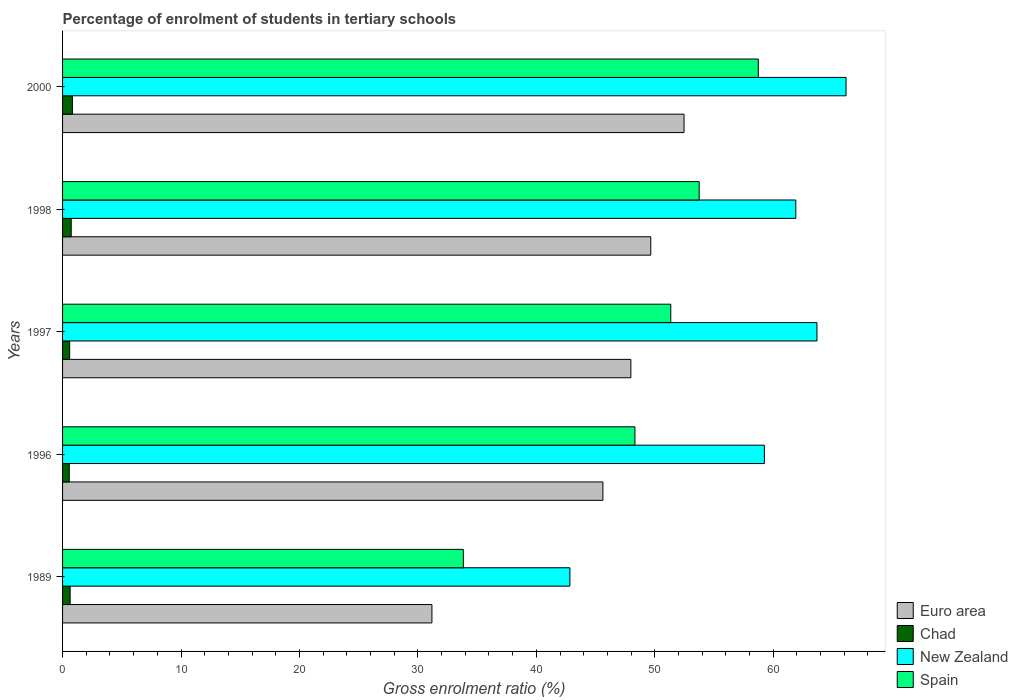How many groups of bars are there?
Your response must be concise. 5. What is the label of the 4th group of bars from the top?
Ensure brevity in your answer.  1996. In how many cases, is the number of bars for a given year not equal to the number of legend labels?
Keep it short and to the point. 0. What is the percentage of students enrolled in tertiary schools in Euro area in 2000?
Ensure brevity in your answer.  52.47. Across all years, what is the maximum percentage of students enrolled in tertiary schools in Chad?
Offer a terse response. 0.83. Across all years, what is the minimum percentage of students enrolled in tertiary schools in Spain?
Offer a terse response. 33.84. In which year was the percentage of students enrolled in tertiary schools in Spain maximum?
Your response must be concise. 2000. What is the total percentage of students enrolled in tertiary schools in New Zealand in the graph?
Give a very brief answer. 293.84. What is the difference between the percentage of students enrolled in tertiary schools in New Zealand in 1989 and that in 1996?
Your response must be concise. -16.42. What is the difference between the percentage of students enrolled in tertiary schools in Spain in 1996 and the percentage of students enrolled in tertiary schools in Chad in 1989?
Make the answer very short. 47.69. What is the average percentage of students enrolled in tertiary schools in Euro area per year?
Provide a succinct answer. 45.38. In the year 1997, what is the difference between the percentage of students enrolled in tertiary schools in New Zealand and percentage of students enrolled in tertiary schools in Spain?
Provide a short and direct response. 12.34. In how many years, is the percentage of students enrolled in tertiary schools in New Zealand greater than 60 %?
Make the answer very short. 3. What is the ratio of the percentage of students enrolled in tertiary schools in Euro area in 1989 to that in 1996?
Your response must be concise. 0.68. Is the percentage of students enrolled in tertiary schools in Chad in 1996 less than that in 1998?
Your answer should be very brief. Yes. What is the difference between the highest and the second highest percentage of students enrolled in tertiary schools in Euro area?
Offer a terse response. 2.81. What is the difference between the highest and the lowest percentage of students enrolled in tertiary schools in Spain?
Your answer should be very brief. 24.9. Is it the case that in every year, the sum of the percentage of students enrolled in tertiary schools in Chad and percentage of students enrolled in tertiary schools in Spain is greater than the sum of percentage of students enrolled in tertiary schools in Euro area and percentage of students enrolled in tertiary schools in New Zealand?
Keep it short and to the point. No. What does the 4th bar from the top in 1998 represents?
Give a very brief answer. Euro area. What does the 3rd bar from the bottom in 1998 represents?
Your answer should be very brief. New Zealand. Is it the case that in every year, the sum of the percentage of students enrolled in tertiary schools in Spain and percentage of students enrolled in tertiary schools in New Zealand is greater than the percentage of students enrolled in tertiary schools in Chad?
Make the answer very short. Yes. How many years are there in the graph?
Provide a short and direct response. 5. Does the graph contain any zero values?
Offer a very short reply. No. Does the graph contain grids?
Give a very brief answer. No. Where does the legend appear in the graph?
Give a very brief answer. Bottom right. What is the title of the graph?
Offer a very short reply. Percentage of enrolment of students in tertiary schools. Does "Benin" appear as one of the legend labels in the graph?
Offer a terse response. No. What is the label or title of the X-axis?
Your answer should be compact. Gross enrolment ratio (%). What is the label or title of the Y-axis?
Ensure brevity in your answer.  Years. What is the Gross enrolment ratio (%) of Euro area in 1989?
Your answer should be compact. 31.19. What is the Gross enrolment ratio (%) of Chad in 1989?
Provide a short and direct response. 0.64. What is the Gross enrolment ratio (%) in New Zealand in 1989?
Keep it short and to the point. 42.84. What is the Gross enrolment ratio (%) in Spain in 1989?
Ensure brevity in your answer.  33.84. What is the Gross enrolment ratio (%) in Euro area in 1996?
Ensure brevity in your answer.  45.62. What is the Gross enrolment ratio (%) of Chad in 1996?
Keep it short and to the point. 0.56. What is the Gross enrolment ratio (%) of New Zealand in 1996?
Provide a succinct answer. 59.26. What is the Gross enrolment ratio (%) of Spain in 1996?
Give a very brief answer. 48.33. What is the Gross enrolment ratio (%) in Euro area in 1997?
Make the answer very short. 47.98. What is the Gross enrolment ratio (%) in Chad in 1997?
Keep it short and to the point. 0.6. What is the Gross enrolment ratio (%) in New Zealand in 1997?
Your answer should be very brief. 63.69. What is the Gross enrolment ratio (%) of Spain in 1997?
Make the answer very short. 51.35. What is the Gross enrolment ratio (%) of Euro area in 1998?
Make the answer very short. 49.66. What is the Gross enrolment ratio (%) in Chad in 1998?
Make the answer very short. 0.73. What is the Gross enrolment ratio (%) in New Zealand in 1998?
Your response must be concise. 61.91. What is the Gross enrolment ratio (%) in Spain in 1998?
Provide a short and direct response. 53.75. What is the Gross enrolment ratio (%) in Euro area in 2000?
Give a very brief answer. 52.47. What is the Gross enrolment ratio (%) in Chad in 2000?
Offer a terse response. 0.83. What is the Gross enrolment ratio (%) in New Zealand in 2000?
Your answer should be very brief. 66.15. What is the Gross enrolment ratio (%) of Spain in 2000?
Give a very brief answer. 58.74. Across all years, what is the maximum Gross enrolment ratio (%) in Euro area?
Provide a short and direct response. 52.47. Across all years, what is the maximum Gross enrolment ratio (%) in Chad?
Your answer should be compact. 0.83. Across all years, what is the maximum Gross enrolment ratio (%) in New Zealand?
Your response must be concise. 66.15. Across all years, what is the maximum Gross enrolment ratio (%) in Spain?
Your answer should be compact. 58.74. Across all years, what is the minimum Gross enrolment ratio (%) in Euro area?
Your answer should be compact. 31.19. Across all years, what is the minimum Gross enrolment ratio (%) in Chad?
Give a very brief answer. 0.56. Across all years, what is the minimum Gross enrolment ratio (%) in New Zealand?
Offer a terse response. 42.84. Across all years, what is the minimum Gross enrolment ratio (%) in Spain?
Provide a succinct answer. 33.84. What is the total Gross enrolment ratio (%) of Euro area in the graph?
Your response must be concise. 226.92. What is the total Gross enrolment ratio (%) of Chad in the graph?
Your answer should be very brief. 3.37. What is the total Gross enrolment ratio (%) of New Zealand in the graph?
Offer a terse response. 293.84. What is the total Gross enrolment ratio (%) in Spain in the graph?
Provide a short and direct response. 246. What is the difference between the Gross enrolment ratio (%) in Euro area in 1989 and that in 1996?
Your answer should be very brief. -14.44. What is the difference between the Gross enrolment ratio (%) of Chad in 1989 and that in 1996?
Make the answer very short. 0.07. What is the difference between the Gross enrolment ratio (%) of New Zealand in 1989 and that in 1996?
Provide a short and direct response. -16.42. What is the difference between the Gross enrolment ratio (%) in Spain in 1989 and that in 1996?
Your answer should be very brief. -14.49. What is the difference between the Gross enrolment ratio (%) in Euro area in 1989 and that in 1997?
Make the answer very short. -16.79. What is the difference between the Gross enrolment ratio (%) in Chad in 1989 and that in 1997?
Provide a succinct answer. 0.04. What is the difference between the Gross enrolment ratio (%) of New Zealand in 1989 and that in 1997?
Keep it short and to the point. -20.86. What is the difference between the Gross enrolment ratio (%) of Spain in 1989 and that in 1997?
Ensure brevity in your answer.  -17.51. What is the difference between the Gross enrolment ratio (%) in Euro area in 1989 and that in 1998?
Offer a terse response. -18.48. What is the difference between the Gross enrolment ratio (%) in Chad in 1989 and that in 1998?
Offer a terse response. -0.09. What is the difference between the Gross enrolment ratio (%) in New Zealand in 1989 and that in 1998?
Give a very brief answer. -19.07. What is the difference between the Gross enrolment ratio (%) in Spain in 1989 and that in 1998?
Offer a terse response. -19.91. What is the difference between the Gross enrolment ratio (%) of Euro area in 1989 and that in 2000?
Your answer should be compact. -21.29. What is the difference between the Gross enrolment ratio (%) of Chad in 1989 and that in 2000?
Your response must be concise. -0.19. What is the difference between the Gross enrolment ratio (%) in New Zealand in 1989 and that in 2000?
Make the answer very short. -23.32. What is the difference between the Gross enrolment ratio (%) of Spain in 1989 and that in 2000?
Provide a succinct answer. -24.9. What is the difference between the Gross enrolment ratio (%) in Euro area in 1996 and that in 1997?
Ensure brevity in your answer.  -2.36. What is the difference between the Gross enrolment ratio (%) in Chad in 1996 and that in 1997?
Offer a very short reply. -0.04. What is the difference between the Gross enrolment ratio (%) in New Zealand in 1996 and that in 1997?
Make the answer very short. -4.44. What is the difference between the Gross enrolment ratio (%) in Spain in 1996 and that in 1997?
Give a very brief answer. -3.03. What is the difference between the Gross enrolment ratio (%) of Euro area in 1996 and that in 1998?
Give a very brief answer. -4.04. What is the difference between the Gross enrolment ratio (%) in Chad in 1996 and that in 1998?
Ensure brevity in your answer.  -0.17. What is the difference between the Gross enrolment ratio (%) in New Zealand in 1996 and that in 1998?
Offer a terse response. -2.65. What is the difference between the Gross enrolment ratio (%) of Spain in 1996 and that in 1998?
Keep it short and to the point. -5.42. What is the difference between the Gross enrolment ratio (%) of Euro area in 1996 and that in 2000?
Make the answer very short. -6.85. What is the difference between the Gross enrolment ratio (%) in Chad in 1996 and that in 2000?
Provide a short and direct response. -0.27. What is the difference between the Gross enrolment ratio (%) in New Zealand in 1996 and that in 2000?
Provide a short and direct response. -6.9. What is the difference between the Gross enrolment ratio (%) in Spain in 1996 and that in 2000?
Your answer should be very brief. -10.41. What is the difference between the Gross enrolment ratio (%) in Euro area in 1997 and that in 1998?
Offer a very short reply. -1.68. What is the difference between the Gross enrolment ratio (%) in Chad in 1997 and that in 1998?
Your answer should be very brief. -0.13. What is the difference between the Gross enrolment ratio (%) in New Zealand in 1997 and that in 1998?
Offer a very short reply. 1.79. What is the difference between the Gross enrolment ratio (%) of Spain in 1997 and that in 1998?
Provide a succinct answer. -2.4. What is the difference between the Gross enrolment ratio (%) of Euro area in 1997 and that in 2000?
Provide a short and direct response. -4.49. What is the difference between the Gross enrolment ratio (%) in Chad in 1997 and that in 2000?
Your answer should be very brief. -0.23. What is the difference between the Gross enrolment ratio (%) in New Zealand in 1997 and that in 2000?
Provide a succinct answer. -2.46. What is the difference between the Gross enrolment ratio (%) of Spain in 1997 and that in 2000?
Give a very brief answer. -7.39. What is the difference between the Gross enrolment ratio (%) in Euro area in 1998 and that in 2000?
Give a very brief answer. -2.81. What is the difference between the Gross enrolment ratio (%) of Chad in 1998 and that in 2000?
Provide a succinct answer. -0.1. What is the difference between the Gross enrolment ratio (%) in New Zealand in 1998 and that in 2000?
Provide a succinct answer. -4.24. What is the difference between the Gross enrolment ratio (%) of Spain in 1998 and that in 2000?
Give a very brief answer. -4.99. What is the difference between the Gross enrolment ratio (%) in Euro area in 1989 and the Gross enrolment ratio (%) in Chad in 1996?
Keep it short and to the point. 30.62. What is the difference between the Gross enrolment ratio (%) in Euro area in 1989 and the Gross enrolment ratio (%) in New Zealand in 1996?
Give a very brief answer. -28.07. What is the difference between the Gross enrolment ratio (%) in Euro area in 1989 and the Gross enrolment ratio (%) in Spain in 1996?
Your answer should be compact. -17.14. What is the difference between the Gross enrolment ratio (%) in Chad in 1989 and the Gross enrolment ratio (%) in New Zealand in 1996?
Ensure brevity in your answer.  -58.62. What is the difference between the Gross enrolment ratio (%) of Chad in 1989 and the Gross enrolment ratio (%) of Spain in 1996?
Your response must be concise. -47.69. What is the difference between the Gross enrolment ratio (%) of New Zealand in 1989 and the Gross enrolment ratio (%) of Spain in 1996?
Provide a succinct answer. -5.49. What is the difference between the Gross enrolment ratio (%) of Euro area in 1989 and the Gross enrolment ratio (%) of Chad in 1997?
Your answer should be very brief. 30.59. What is the difference between the Gross enrolment ratio (%) of Euro area in 1989 and the Gross enrolment ratio (%) of New Zealand in 1997?
Your answer should be very brief. -32.51. What is the difference between the Gross enrolment ratio (%) of Euro area in 1989 and the Gross enrolment ratio (%) of Spain in 1997?
Your answer should be compact. -20.16. What is the difference between the Gross enrolment ratio (%) in Chad in 1989 and the Gross enrolment ratio (%) in New Zealand in 1997?
Your answer should be compact. -63.05. What is the difference between the Gross enrolment ratio (%) in Chad in 1989 and the Gross enrolment ratio (%) in Spain in 1997?
Give a very brief answer. -50.71. What is the difference between the Gross enrolment ratio (%) of New Zealand in 1989 and the Gross enrolment ratio (%) of Spain in 1997?
Your answer should be very brief. -8.52. What is the difference between the Gross enrolment ratio (%) of Euro area in 1989 and the Gross enrolment ratio (%) of Chad in 1998?
Your answer should be compact. 30.46. What is the difference between the Gross enrolment ratio (%) of Euro area in 1989 and the Gross enrolment ratio (%) of New Zealand in 1998?
Your response must be concise. -30.72. What is the difference between the Gross enrolment ratio (%) in Euro area in 1989 and the Gross enrolment ratio (%) in Spain in 1998?
Give a very brief answer. -22.56. What is the difference between the Gross enrolment ratio (%) in Chad in 1989 and the Gross enrolment ratio (%) in New Zealand in 1998?
Your answer should be very brief. -61.27. What is the difference between the Gross enrolment ratio (%) of Chad in 1989 and the Gross enrolment ratio (%) of Spain in 1998?
Your answer should be compact. -53.11. What is the difference between the Gross enrolment ratio (%) of New Zealand in 1989 and the Gross enrolment ratio (%) of Spain in 1998?
Your response must be concise. -10.91. What is the difference between the Gross enrolment ratio (%) in Euro area in 1989 and the Gross enrolment ratio (%) in Chad in 2000?
Ensure brevity in your answer.  30.36. What is the difference between the Gross enrolment ratio (%) of Euro area in 1989 and the Gross enrolment ratio (%) of New Zealand in 2000?
Give a very brief answer. -34.96. What is the difference between the Gross enrolment ratio (%) in Euro area in 1989 and the Gross enrolment ratio (%) in Spain in 2000?
Your response must be concise. -27.55. What is the difference between the Gross enrolment ratio (%) of Chad in 1989 and the Gross enrolment ratio (%) of New Zealand in 2000?
Your answer should be compact. -65.51. What is the difference between the Gross enrolment ratio (%) in Chad in 1989 and the Gross enrolment ratio (%) in Spain in 2000?
Make the answer very short. -58.1. What is the difference between the Gross enrolment ratio (%) in New Zealand in 1989 and the Gross enrolment ratio (%) in Spain in 2000?
Your answer should be very brief. -15.9. What is the difference between the Gross enrolment ratio (%) in Euro area in 1996 and the Gross enrolment ratio (%) in Chad in 1997?
Your response must be concise. 45.02. What is the difference between the Gross enrolment ratio (%) in Euro area in 1996 and the Gross enrolment ratio (%) in New Zealand in 1997?
Your response must be concise. -18.07. What is the difference between the Gross enrolment ratio (%) of Euro area in 1996 and the Gross enrolment ratio (%) of Spain in 1997?
Your answer should be compact. -5.73. What is the difference between the Gross enrolment ratio (%) of Chad in 1996 and the Gross enrolment ratio (%) of New Zealand in 1997?
Make the answer very short. -63.13. What is the difference between the Gross enrolment ratio (%) of Chad in 1996 and the Gross enrolment ratio (%) of Spain in 1997?
Give a very brief answer. -50.79. What is the difference between the Gross enrolment ratio (%) of New Zealand in 1996 and the Gross enrolment ratio (%) of Spain in 1997?
Ensure brevity in your answer.  7.9. What is the difference between the Gross enrolment ratio (%) in Euro area in 1996 and the Gross enrolment ratio (%) in Chad in 1998?
Your response must be concise. 44.89. What is the difference between the Gross enrolment ratio (%) in Euro area in 1996 and the Gross enrolment ratio (%) in New Zealand in 1998?
Give a very brief answer. -16.29. What is the difference between the Gross enrolment ratio (%) of Euro area in 1996 and the Gross enrolment ratio (%) of Spain in 1998?
Keep it short and to the point. -8.13. What is the difference between the Gross enrolment ratio (%) in Chad in 1996 and the Gross enrolment ratio (%) in New Zealand in 1998?
Give a very brief answer. -61.34. What is the difference between the Gross enrolment ratio (%) in Chad in 1996 and the Gross enrolment ratio (%) in Spain in 1998?
Keep it short and to the point. -53.18. What is the difference between the Gross enrolment ratio (%) of New Zealand in 1996 and the Gross enrolment ratio (%) of Spain in 1998?
Keep it short and to the point. 5.51. What is the difference between the Gross enrolment ratio (%) of Euro area in 1996 and the Gross enrolment ratio (%) of Chad in 2000?
Your answer should be very brief. 44.79. What is the difference between the Gross enrolment ratio (%) of Euro area in 1996 and the Gross enrolment ratio (%) of New Zealand in 2000?
Keep it short and to the point. -20.53. What is the difference between the Gross enrolment ratio (%) of Euro area in 1996 and the Gross enrolment ratio (%) of Spain in 2000?
Provide a succinct answer. -13.12. What is the difference between the Gross enrolment ratio (%) of Chad in 1996 and the Gross enrolment ratio (%) of New Zealand in 2000?
Make the answer very short. -65.59. What is the difference between the Gross enrolment ratio (%) in Chad in 1996 and the Gross enrolment ratio (%) in Spain in 2000?
Your answer should be compact. -58.18. What is the difference between the Gross enrolment ratio (%) of New Zealand in 1996 and the Gross enrolment ratio (%) of Spain in 2000?
Provide a short and direct response. 0.52. What is the difference between the Gross enrolment ratio (%) of Euro area in 1997 and the Gross enrolment ratio (%) of Chad in 1998?
Your response must be concise. 47.25. What is the difference between the Gross enrolment ratio (%) of Euro area in 1997 and the Gross enrolment ratio (%) of New Zealand in 1998?
Give a very brief answer. -13.93. What is the difference between the Gross enrolment ratio (%) in Euro area in 1997 and the Gross enrolment ratio (%) in Spain in 1998?
Provide a short and direct response. -5.77. What is the difference between the Gross enrolment ratio (%) of Chad in 1997 and the Gross enrolment ratio (%) of New Zealand in 1998?
Make the answer very short. -61.31. What is the difference between the Gross enrolment ratio (%) in Chad in 1997 and the Gross enrolment ratio (%) in Spain in 1998?
Provide a short and direct response. -53.15. What is the difference between the Gross enrolment ratio (%) of New Zealand in 1997 and the Gross enrolment ratio (%) of Spain in 1998?
Your answer should be compact. 9.94. What is the difference between the Gross enrolment ratio (%) in Euro area in 1997 and the Gross enrolment ratio (%) in Chad in 2000?
Your answer should be very brief. 47.15. What is the difference between the Gross enrolment ratio (%) of Euro area in 1997 and the Gross enrolment ratio (%) of New Zealand in 2000?
Your response must be concise. -18.17. What is the difference between the Gross enrolment ratio (%) of Euro area in 1997 and the Gross enrolment ratio (%) of Spain in 2000?
Provide a succinct answer. -10.76. What is the difference between the Gross enrolment ratio (%) in Chad in 1997 and the Gross enrolment ratio (%) in New Zealand in 2000?
Your answer should be compact. -65.55. What is the difference between the Gross enrolment ratio (%) of Chad in 1997 and the Gross enrolment ratio (%) of Spain in 2000?
Offer a very short reply. -58.14. What is the difference between the Gross enrolment ratio (%) in New Zealand in 1997 and the Gross enrolment ratio (%) in Spain in 2000?
Offer a terse response. 4.95. What is the difference between the Gross enrolment ratio (%) of Euro area in 1998 and the Gross enrolment ratio (%) of Chad in 2000?
Your response must be concise. 48.83. What is the difference between the Gross enrolment ratio (%) in Euro area in 1998 and the Gross enrolment ratio (%) in New Zealand in 2000?
Offer a terse response. -16.49. What is the difference between the Gross enrolment ratio (%) in Euro area in 1998 and the Gross enrolment ratio (%) in Spain in 2000?
Offer a terse response. -9.08. What is the difference between the Gross enrolment ratio (%) of Chad in 1998 and the Gross enrolment ratio (%) of New Zealand in 2000?
Keep it short and to the point. -65.42. What is the difference between the Gross enrolment ratio (%) in Chad in 1998 and the Gross enrolment ratio (%) in Spain in 2000?
Your answer should be compact. -58.01. What is the difference between the Gross enrolment ratio (%) in New Zealand in 1998 and the Gross enrolment ratio (%) in Spain in 2000?
Your answer should be very brief. 3.17. What is the average Gross enrolment ratio (%) of Euro area per year?
Keep it short and to the point. 45.38. What is the average Gross enrolment ratio (%) in Chad per year?
Give a very brief answer. 0.67. What is the average Gross enrolment ratio (%) in New Zealand per year?
Make the answer very short. 58.77. What is the average Gross enrolment ratio (%) in Spain per year?
Provide a short and direct response. 49.2. In the year 1989, what is the difference between the Gross enrolment ratio (%) of Euro area and Gross enrolment ratio (%) of Chad?
Your answer should be compact. 30.55. In the year 1989, what is the difference between the Gross enrolment ratio (%) of Euro area and Gross enrolment ratio (%) of New Zealand?
Provide a short and direct response. -11.65. In the year 1989, what is the difference between the Gross enrolment ratio (%) in Euro area and Gross enrolment ratio (%) in Spain?
Offer a very short reply. -2.65. In the year 1989, what is the difference between the Gross enrolment ratio (%) of Chad and Gross enrolment ratio (%) of New Zealand?
Offer a very short reply. -42.2. In the year 1989, what is the difference between the Gross enrolment ratio (%) in Chad and Gross enrolment ratio (%) in Spain?
Your answer should be very brief. -33.2. In the year 1989, what is the difference between the Gross enrolment ratio (%) in New Zealand and Gross enrolment ratio (%) in Spain?
Ensure brevity in your answer.  9. In the year 1996, what is the difference between the Gross enrolment ratio (%) in Euro area and Gross enrolment ratio (%) in Chad?
Offer a terse response. 45.06. In the year 1996, what is the difference between the Gross enrolment ratio (%) of Euro area and Gross enrolment ratio (%) of New Zealand?
Offer a very short reply. -13.63. In the year 1996, what is the difference between the Gross enrolment ratio (%) in Euro area and Gross enrolment ratio (%) in Spain?
Your response must be concise. -2.7. In the year 1996, what is the difference between the Gross enrolment ratio (%) of Chad and Gross enrolment ratio (%) of New Zealand?
Offer a terse response. -58.69. In the year 1996, what is the difference between the Gross enrolment ratio (%) of Chad and Gross enrolment ratio (%) of Spain?
Give a very brief answer. -47.76. In the year 1996, what is the difference between the Gross enrolment ratio (%) in New Zealand and Gross enrolment ratio (%) in Spain?
Keep it short and to the point. 10.93. In the year 1997, what is the difference between the Gross enrolment ratio (%) of Euro area and Gross enrolment ratio (%) of Chad?
Offer a terse response. 47.38. In the year 1997, what is the difference between the Gross enrolment ratio (%) of Euro area and Gross enrolment ratio (%) of New Zealand?
Make the answer very short. -15.71. In the year 1997, what is the difference between the Gross enrolment ratio (%) in Euro area and Gross enrolment ratio (%) in Spain?
Offer a very short reply. -3.37. In the year 1997, what is the difference between the Gross enrolment ratio (%) in Chad and Gross enrolment ratio (%) in New Zealand?
Provide a short and direct response. -63.09. In the year 1997, what is the difference between the Gross enrolment ratio (%) in Chad and Gross enrolment ratio (%) in Spain?
Offer a terse response. -50.75. In the year 1997, what is the difference between the Gross enrolment ratio (%) of New Zealand and Gross enrolment ratio (%) of Spain?
Offer a terse response. 12.34. In the year 1998, what is the difference between the Gross enrolment ratio (%) of Euro area and Gross enrolment ratio (%) of Chad?
Provide a succinct answer. 48.93. In the year 1998, what is the difference between the Gross enrolment ratio (%) of Euro area and Gross enrolment ratio (%) of New Zealand?
Keep it short and to the point. -12.25. In the year 1998, what is the difference between the Gross enrolment ratio (%) in Euro area and Gross enrolment ratio (%) in Spain?
Your response must be concise. -4.09. In the year 1998, what is the difference between the Gross enrolment ratio (%) of Chad and Gross enrolment ratio (%) of New Zealand?
Offer a terse response. -61.18. In the year 1998, what is the difference between the Gross enrolment ratio (%) of Chad and Gross enrolment ratio (%) of Spain?
Your answer should be compact. -53.02. In the year 1998, what is the difference between the Gross enrolment ratio (%) in New Zealand and Gross enrolment ratio (%) in Spain?
Your answer should be very brief. 8.16. In the year 2000, what is the difference between the Gross enrolment ratio (%) in Euro area and Gross enrolment ratio (%) in Chad?
Provide a succinct answer. 51.64. In the year 2000, what is the difference between the Gross enrolment ratio (%) in Euro area and Gross enrolment ratio (%) in New Zealand?
Your response must be concise. -13.68. In the year 2000, what is the difference between the Gross enrolment ratio (%) of Euro area and Gross enrolment ratio (%) of Spain?
Offer a terse response. -6.27. In the year 2000, what is the difference between the Gross enrolment ratio (%) of Chad and Gross enrolment ratio (%) of New Zealand?
Ensure brevity in your answer.  -65.32. In the year 2000, what is the difference between the Gross enrolment ratio (%) in Chad and Gross enrolment ratio (%) in Spain?
Your response must be concise. -57.91. In the year 2000, what is the difference between the Gross enrolment ratio (%) of New Zealand and Gross enrolment ratio (%) of Spain?
Provide a short and direct response. 7.41. What is the ratio of the Gross enrolment ratio (%) in Euro area in 1989 to that in 1996?
Keep it short and to the point. 0.68. What is the ratio of the Gross enrolment ratio (%) of Chad in 1989 to that in 1996?
Ensure brevity in your answer.  1.13. What is the ratio of the Gross enrolment ratio (%) in New Zealand in 1989 to that in 1996?
Offer a terse response. 0.72. What is the ratio of the Gross enrolment ratio (%) in Spain in 1989 to that in 1996?
Make the answer very short. 0.7. What is the ratio of the Gross enrolment ratio (%) in Euro area in 1989 to that in 1997?
Provide a short and direct response. 0.65. What is the ratio of the Gross enrolment ratio (%) of Chad in 1989 to that in 1997?
Ensure brevity in your answer.  1.06. What is the ratio of the Gross enrolment ratio (%) in New Zealand in 1989 to that in 1997?
Offer a terse response. 0.67. What is the ratio of the Gross enrolment ratio (%) of Spain in 1989 to that in 1997?
Offer a very short reply. 0.66. What is the ratio of the Gross enrolment ratio (%) in Euro area in 1989 to that in 1998?
Give a very brief answer. 0.63. What is the ratio of the Gross enrolment ratio (%) in Chad in 1989 to that in 1998?
Make the answer very short. 0.87. What is the ratio of the Gross enrolment ratio (%) of New Zealand in 1989 to that in 1998?
Offer a very short reply. 0.69. What is the ratio of the Gross enrolment ratio (%) of Spain in 1989 to that in 1998?
Ensure brevity in your answer.  0.63. What is the ratio of the Gross enrolment ratio (%) of Euro area in 1989 to that in 2000?
Provide a succinct answer. 0.59. What is the ratio of the Gross enrolment ratio (%) of Chad in 1989 to that in 2000?
Ensure brevity in your answer.  0.77. What is the ratio of the Gross enrolment ratio (%) in New Zealand in 1989 to that in 2000?
Offer a very short reply. 0.65. What is the ratio of the Gross enrolment ratio (%) in Spain in 1989 to that in 2000?
Your answer should be very brief. 0.58. What is the ratio of the Gross enrolment ratio (%) in Euro area in 1996 to that in 1997?
Make the answer very short. 0.95. What is the ratio of the Gross enrolment ratio (%) in Chad in 1996 to that in 1997?
Provide a succinct answer. 0.94. What is the ratio of the Gross enrolment ratio (%) of New Zealand in 1996 to that in 1997?
Keep it short and to the point. 0.93. What is the ratio of the Gross enrolment ratio (%) in Spain in 1996 to that in 1997?
Your response must be concise. 0.94. What is the ratio of the Gross enrolment ratio (%) of Euro area in 1996 to that in 1998?
Your answer should be very brief. 0.92. What is the ratio of the Gross enrolment ratio (%) in Chad in 1996 to that in 1998?
Offer a terse response. 0.77. What is the ratio of the Gross enrolment ratio (%) of New Zealand in 1996 to that in 1998?
Offer a terse response. 0.96. What is the ratio of the Gross enrolment ratio (%) of Spain in 1996 to that in 1998?
Give a very brief answer. 0.9. What is the ratio of the Gross enrolment ratio (%) in Euro area in 1996 to that in 2000?
Your answer should be very brief. 0.87. What is the ratio of the Gross enrolment ratio (%) in Chad in 1996 to that in 2000?
Your answer should be compact. 0.68. What is the ratio of the Gross enrolment ratio (%) of New Zealand in 1996 to that in 2000?
Offer a terse response. 0.9. What is the ratio of the Gross enrolment ratio (%) of Spain in 1996 to that in 2000?
Provide a short and direct response. 0.82. What is the ratio of the Gross enrolment ratio (%) of Euro area in 1997 to that in 1998?
Make the answer very short. 0.97. What is the ratio of the Gross enrolment ratio (%) of Chad in 1997 to that in 1998?
Your answer should be very brief. 0.82. What is the ratio of the Gross enrolment ratio (%) of New Zealand in 1997 to that in 1998?
Give a very brief answer. 1.03. What is the ratio of the Gross enrolment ratio (%) of Spain in 1997 to that in 1998?
Ensure brevity in your answer.  0.96. What is the ratio of the Gross enrolment ratio (%) of Euro area in 1997 to that in 2000?
Your response must be concise. 0.91. What is the ratio of the Gross enrolment ratio (%) of Chad in 1997 to that in 2000?
Your answer should be very brief. 0.72. What is the ratio of the Gross enrolment ratio (%) in New Zealand in 1997 to that in 2000?
Offer a very short reply. 0.96. What is the ratio of the Gross enrolment ratio (%) in Spain in 1997 to that in 2000?
Your answer should be compact. 0.87. What is the ratio of the Gross enrolment ratio (%) in Euro area in 1998 to that in 2000?
Ensure brevity in your answer.  0.95. What is the ratio of the Gross enrolment ratio (%) in Chad in 1998 to that in 2000?
Keep it short and to the point. 0.88. What is the ratio of the Gross enrolment ratio (%) in New Zealand in 1998 to that in 2000?
Provide a succinct answer. 0.94. What is the ratio of the Gross enrolment ratio (%) in Spain in 1998 to that in 2000?
Your response must be concise. 0.92. What is the difference between the highest and the second highest Gross enrolment ratio (%) in Euro area?
Your answer should be compact. 2.81. What is the difference between the highest and the second highest Gross enrolment ratio (%) in Chad?
Make the answer very short. 0.1. What is the difference between the highest and the second highest Gross enrolment ratio (%) of New Zealand?
Make the answer very short. 2.46. What is the difference between the highest and the second highest Gross enrolment ratio (%) of Spain?
Give a very brief answer. 4.99. What is the difference between the highest and the lowest Gross enrolment ratio (%) in Euro area?
Your answer should be very brief. 21.29. What is the difference between the highest and the lowest Gross enrolment ratio (%) of Chad?
Keep it short and to the point. 0.27. What is the difference between the highest and the lowest Gross enrolment ratio (%) of New Zealand?
Provide a short and direct response. 23.32. What is the difference between the highest and the lowest Gross enrolment ratio (%) of Spain?
Keep it short and to the point. 24.9. 